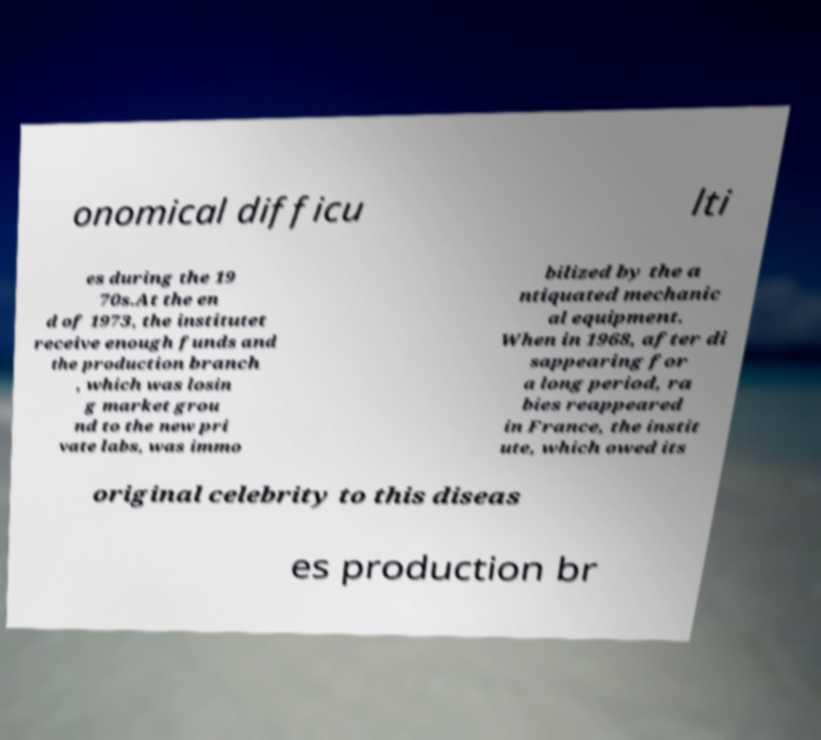I need the written content from this picture converted into text. Can you do that? onomical difficu lti es during the 19 70s.At the en d of 1973, the institutet receive enough funds and the production branch , which was losin g market grou nd to the new pri vate labs, was immo bilized by the a ntiquated mechanic al equipment. When in 1968, after di sappearing for a long period, ra bies reappeared in France, the instit ute, which owed its original celebrity to this diseas es production br 